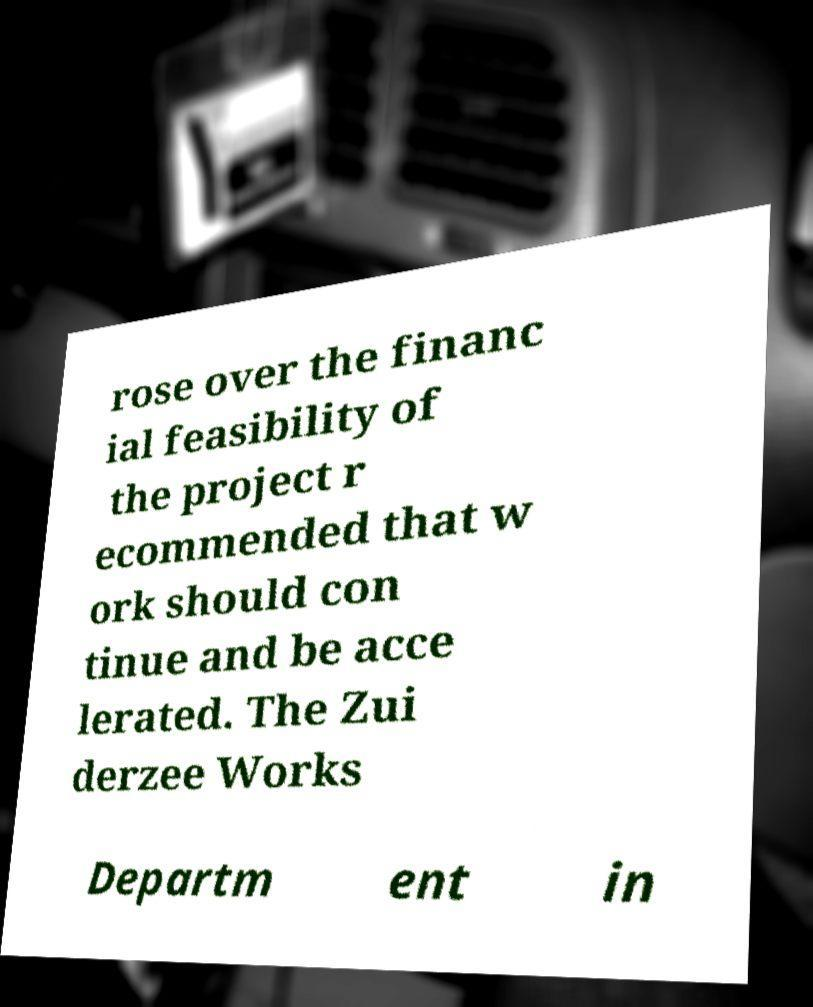Could you extract and type out the text from this image? rose over the financ ial feasibility of the project r ecommended that w ork should con tinue and be acce lerated. The Zui derzee Works Departm ent in 